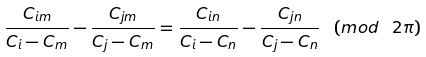Convert formula to latex. <formula><loc_0><loc_0><loc_500><loc_500>\frac { C _ { i m } } { C _ { i } - C _ { m } } - \frac { C _ { j m } } { C _ { j } - C _ { m } } = \frac { C _ { i n } } { C _ { i } - C _ { n } } - \frac { C _ { j n } } { C _ { j } - C _ { n } } \, \ ( m o d \, \ 2 \pi )</formula> 